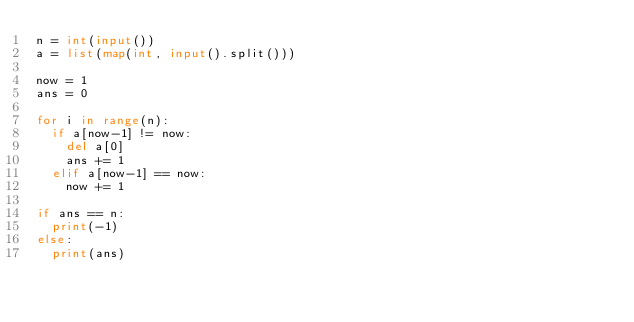<code> <loc_0><loc_0><loc_500><loc_500><_Python_>n = int(input())
a = list(map(int, input().split()))

now = 1
ans = 0

for i in range(n):
  if a[now-1] != now:
    del a[0]
    ans += 1
  elif a[now-1] == now:
    now += 1

if ans == n:
  print(-1)
else:
  print(ans)
</code> 